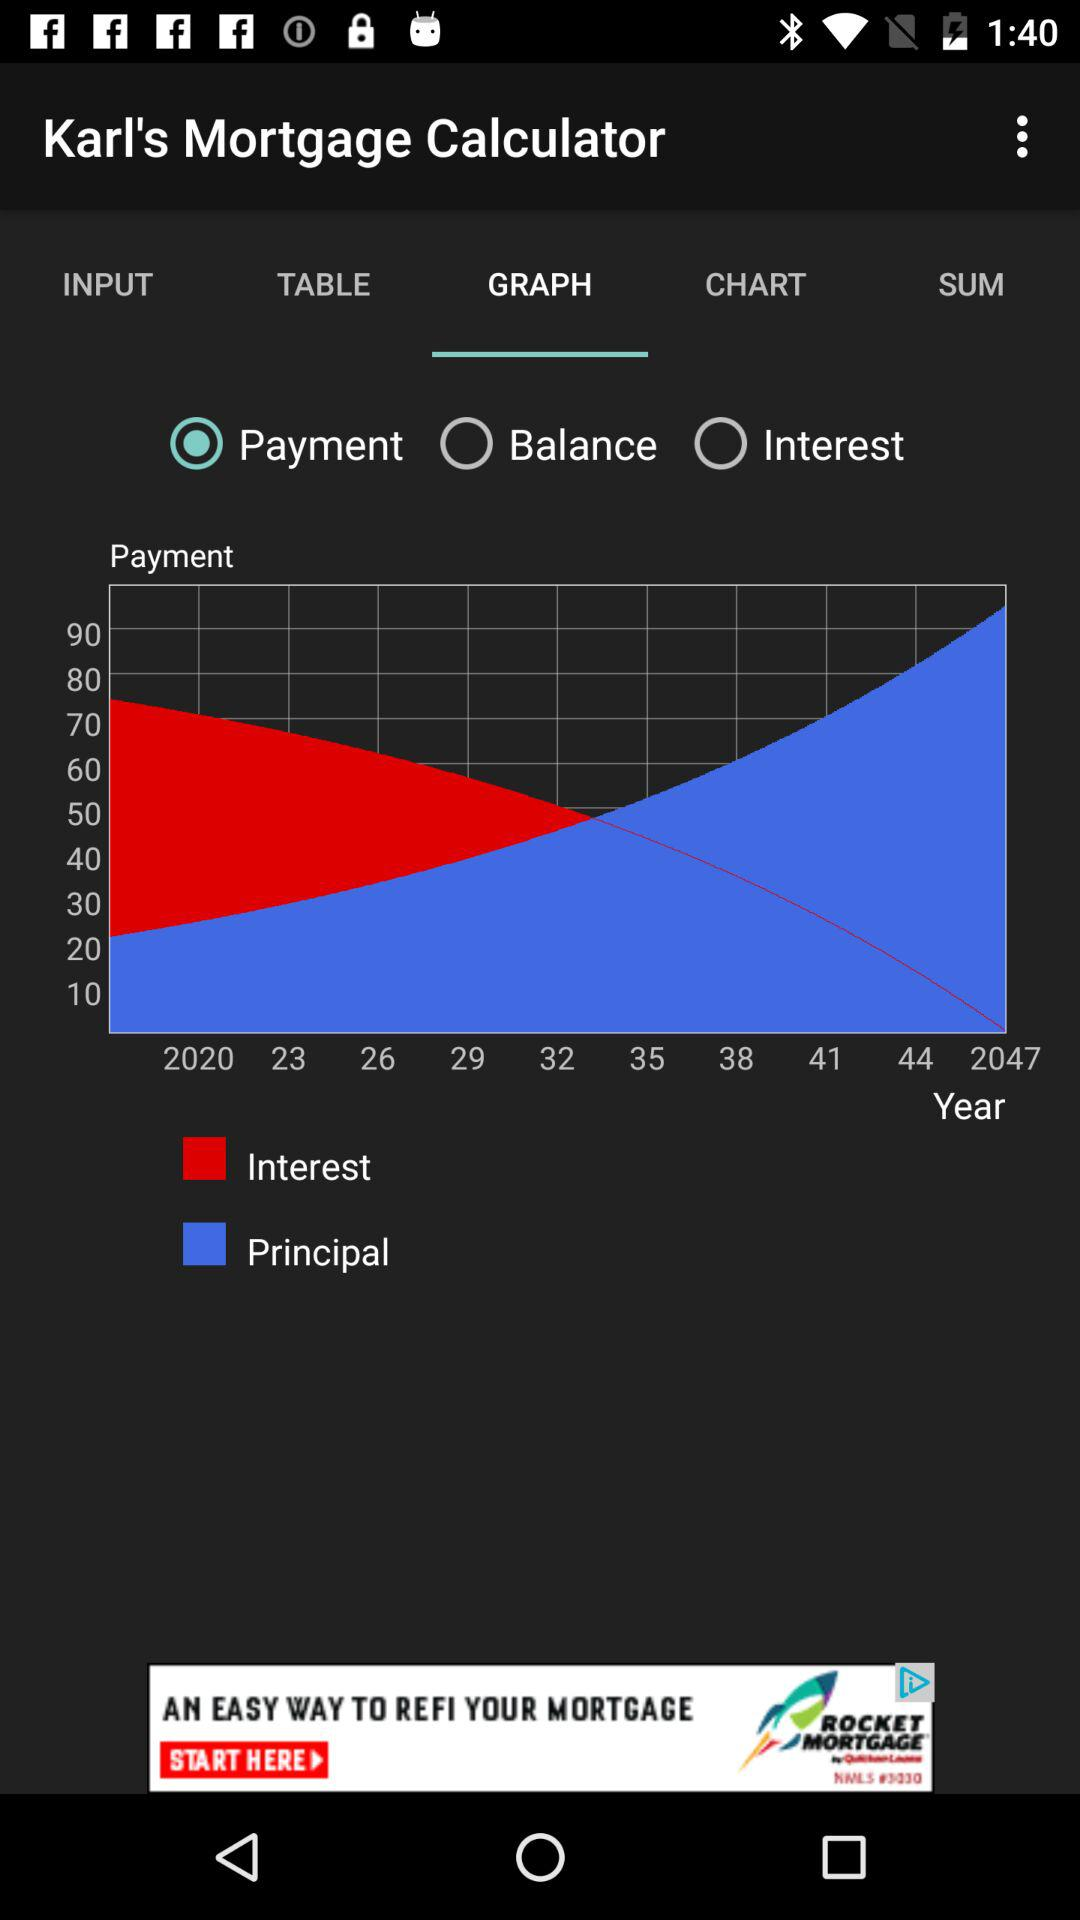Which option is selected? The selected option is "Payment". 